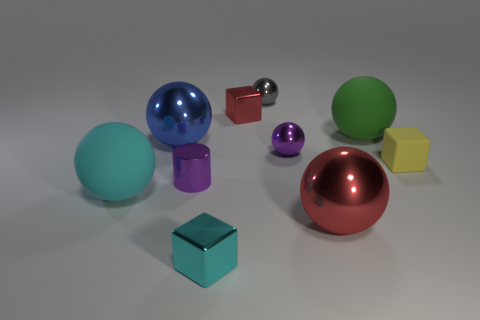Subtract all small red metal blocks. How many blocks are left? 2 Subtract all red blocks. How many blocks are left? 2 Subtract all spheres. How many objects are left? 4 Subtract 3 cubes. How many cubes are left? 0 Subtract all brown cylinders. Subtract all gray blocks. How many cylinders are left? 1 Subtract all blue blocks. How many purple balls are left? 1 Subtract all blocks. Subtract all big green metallic things. How many objects are left? 7 Add 4 big green rubber balls. How many big green rubber balls are left? 5 Add 4 green spheres. How many green spheres exist? 5 Subtract 0 green cylinders. How many objects are left? 10 